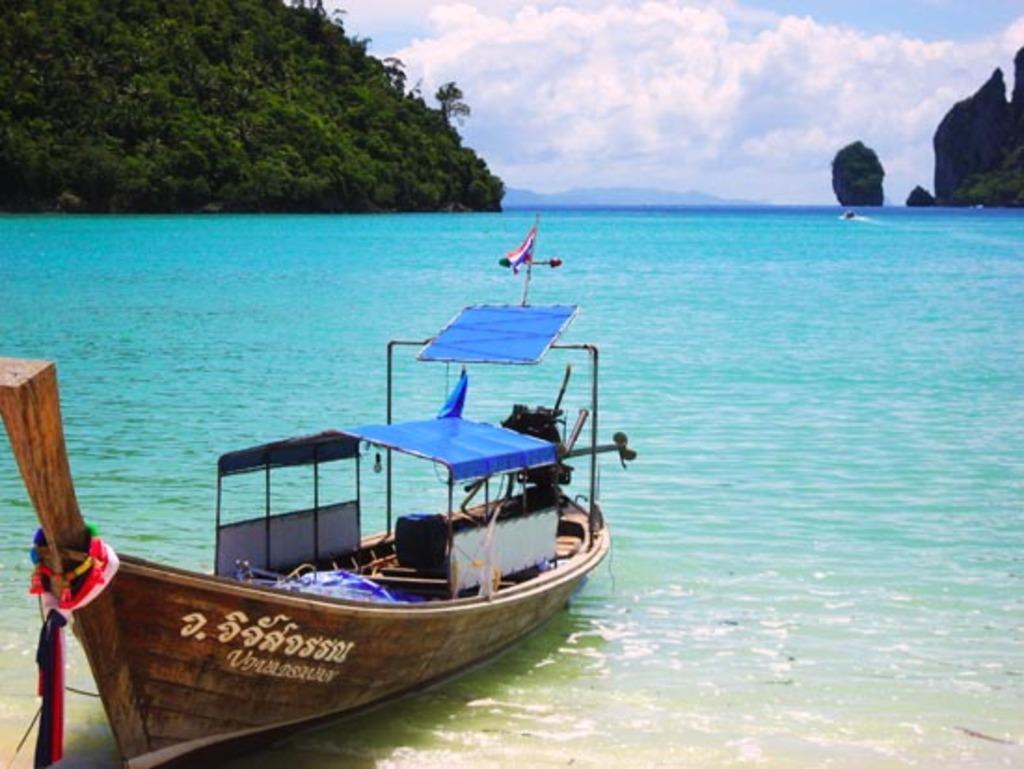In one or two sentences, can you explain what this image depicts? On the left side, there is a boat on the water. In the background, there are mountains and there are clouds in the sky. 